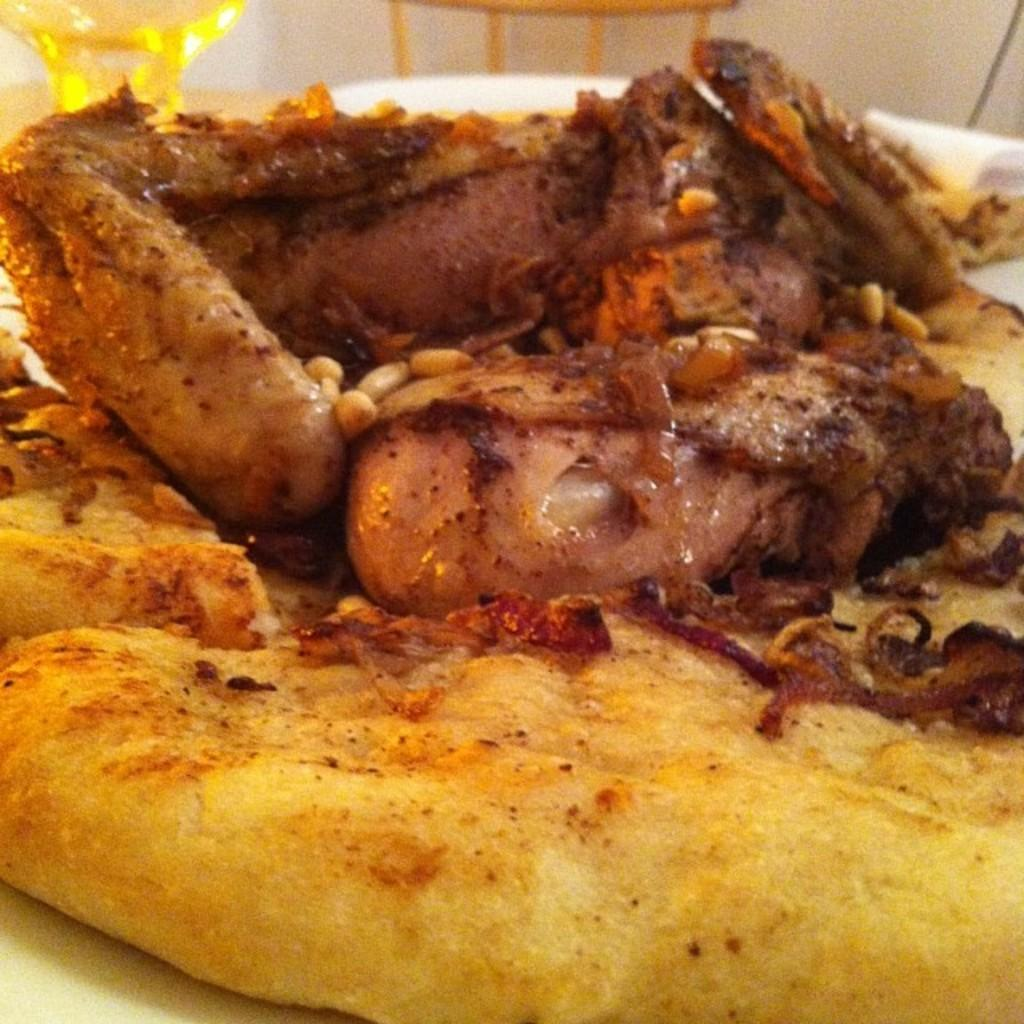What type of surface is the eatable things placed on in the image? The eatable things are placed on a white surface in the image. What type of container is visible in the image? There is a glass in the image. Can you describe any other objects in the image besides the eatable things and the glass? There are unspecified objects in the image. What type of car is parked near the eatable things in the image? There is no car present in the image; it only features eatable things, a glass, and unspecified objects. 